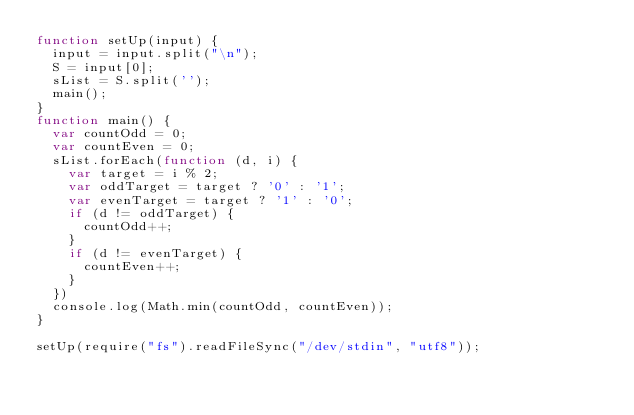<code> <loc_0><loc_0><loc_500><loc_500><_JavaScript_>function setUp(input) {
  input = input.split("\n");
  S = input[0];
  sList = S.split('');
  main();
}
function main() {
  var countOdd = 0;
  var countEven = 0;
  sList.forEach(function (d, i) {
    var target = i % 2;
    var oddTarget = target ? '0' : '1';
    var evenTarget = target ? '1' : '0';
    if (d != oddTarget) {
      countOdd++;
    }
    if (d != evenTarget) {
      countEven++;
    }
  })
  console.log(Math.min(countOdd, countEven));
}

setUp(require("fs").readFileSync("/dev/stdin", "utf8"));</code> 